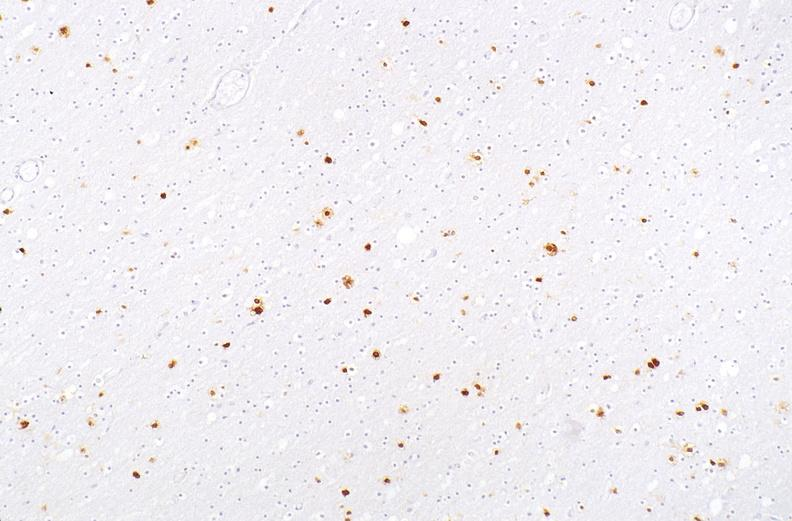does newborn cord around neck show herpes simplex virus, brain, immunohistochemistry?
Answer the question using a single word or phrase. No 